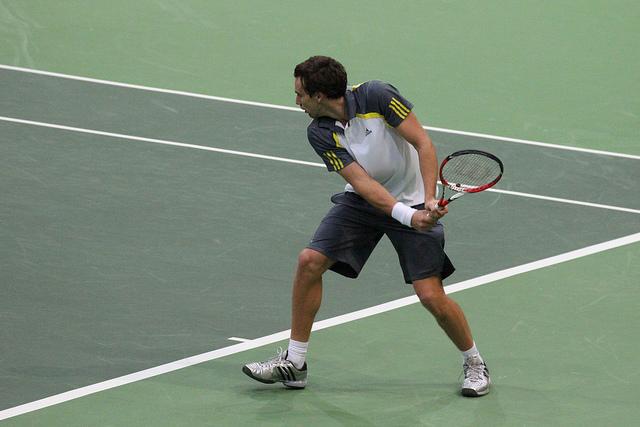What color is the court?
Concise answer only. Green. Has this photo been reversed from left to right?
Answer briefly. No. What color is the racket?
Give a very brief answer. Red and black. Is he holding the racket with one hand?
Short answer required. No. What two words describe the shirt the player is wearing?
Concise answer only. Tennis shirt. Is the player running?
Write a very short answer. No. What is the tennis player doing?
Concise answer only. Playing. 